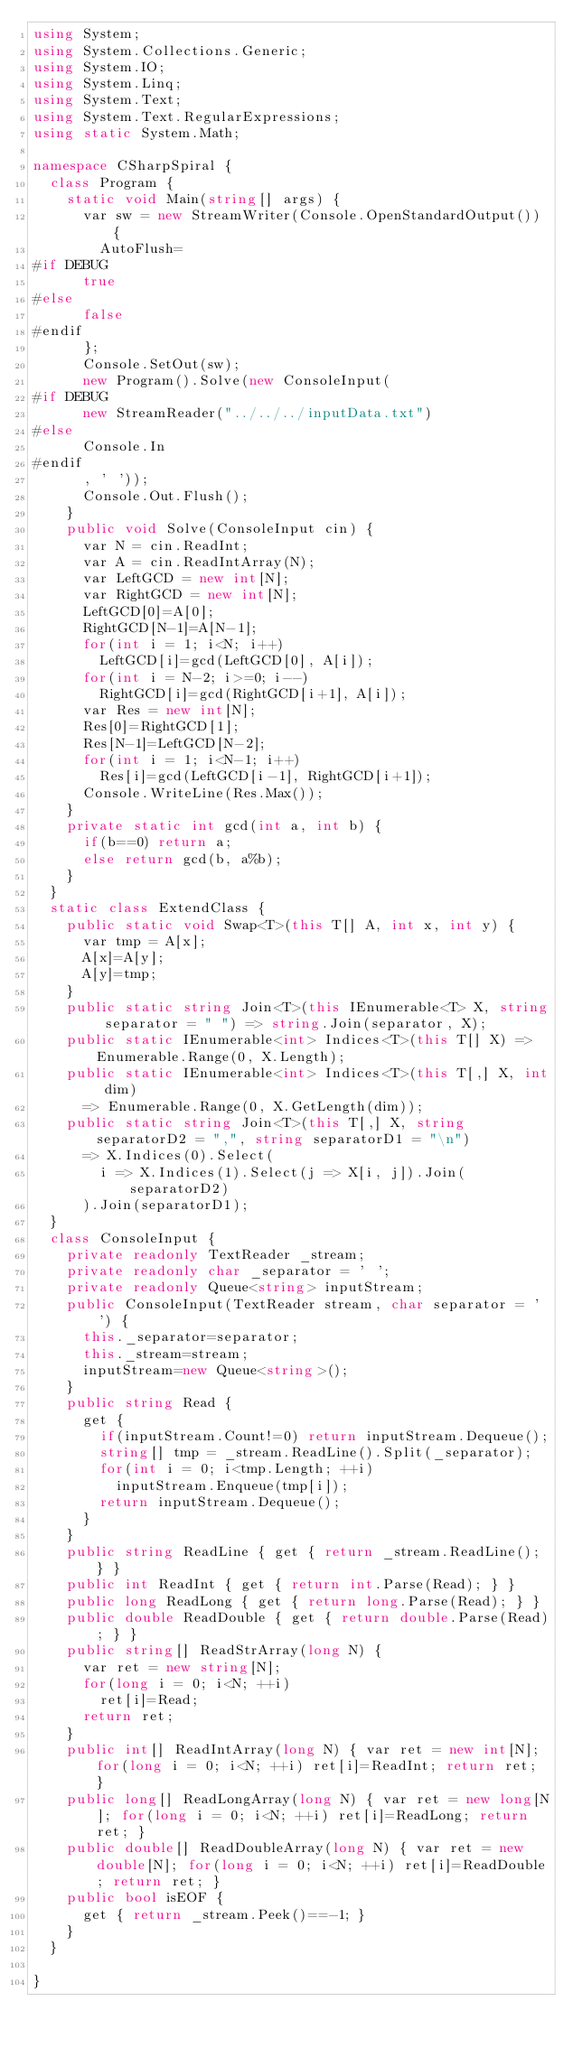<code> <loc_0><loc_0><loc_500><loc_500><_C#_>using System;
using System.Collections.Generic;
using System.IO;
using System.Linq;
using System.Text;
using System.Text.RegularExpressions;
using static System.Math;

namespace CSharpSpiral {
	class Program {
		static void Main(string[] args) {
			var sw = new StreamWriter(Console.OpenStandardOutput()) {
				AutoFlush=
#if DEBUG
			true
#else
			false
#endif
			};
			Console.SetOut(sw);
			new Program().Solve(new ConsoleInput(
#if DEBUG
			new StreamReader("../../../inputData.txt")
#else
			Console.In
#endif
			, ' '));
			Console.Out.Flush();
		}
		public void Solve(ConsoleInput cin) {
			var N = cin.ReadInt;
			var A = cin.ReadIntArray(N);
			var LeftGCD = new int[N];
			var RightGCD = new int[N];
			LeftGCD[0]=A[0];
			RightGCD[N-1]=A[N-1];
			for(int i = 1; i<N; i++) 
				LeftGCD[i]=gcd(LeftGCD[0], A[i]);
			for(int i = N-2; i>=0; i--) 
				RightGCD[i]=gcd(RightGCD[i+1], A[i]);
			var Res = new int[N];
			Res[0]=RightGCD[1];
			Res[N-1]=LeftGCD[N-2];
			for(int i = 1; i<N-1; i++) 
				Res[i]=gcd(LeftGCD[i-1], RightGCD[i+1]);
			Console.WriteLine(Res.Max());
		}
		private static int gcd(int a, int b) {
			if(b==0) return a;
			else return gcd(b, a%b);
		}
	}
	static class ExtendClass {
		public static void Swap<T>(this T[] A, int x, int y) {
			var tmp = A[x];
			A[x]=A[y];
			A[y]=tmp;
		}
		public static string Join<T>(this IEnumerable<T> X, string separator = " ") => string.Join(separator, X);
		public static IEnumerable<int> Indices<T>(this T[] X) => Enumerable.Range(0, X.Length);
		public static IEnumerable<int> Indices<T>(this T[,] X, int dim)
			=> Enumerable.Range(0, X.GetLength(dim));
		public static string Join<T>(this T[,] X, string separatorD2 = ",", string separatorD1 = "\n")
			=> X.Indices(0).Select(
				i => X.Indices(1).Select(j => X[i, j]).Join(separatorD2)
			).Join(separatorD1);
	}
	class ConsoleInput {
		private readonly TextReader _stream;
		private readonly char _separator = ' ';
		private readonly Queue<string> inputStream;
		public ConsoleInput(TextReader stream, char separator = ' ') {
			this._separator=separator;
			this._stream=stream;
			inputStream=new Queue<string>();
		}
		public string Read {
			get {
				if(inputStream.Count!=0) return inputStream.Dequeue();
				string[] tmp = _stream.ReadLine().Split(_separator);
				for(int i = 0; i<tmp.Length; ++i)
					inputStream.Enqueue(tmp[i]);
				return inputStream.Dequeue();
			}
		}
		public string ReadLine { get { return _stream.ReadLine(); } }
		public int ReadInt { get { return int.Parse(Read); } }
		public long ReadLong { get { return long.Parse(Read); } }
		public double ReadDouble { get { return double.Parse(Read); } }
		public string[] ReadStrArray(long N) {
			var ret = new string[N];
			for(long i = 0; i<N; ++i)
				ret[i]=Read;
			return ret;
		}
		public int[] ReadIntArray(long N) { var ret = new int[N]; for(long i = 0; i<N; ++i) ret[i]=ReadInt; return ret; }
		public long[] ReadLongArray(long N) { var ret = new long[N]; for(long i = 0; i<N; ++i) ret[i]=ReadLong; return ret; }
		public double[] ReadDoubleArray(long N) { var ret = new double[N]; for(long i = 0; i<N; ++i) ret[i]=ReadDouble; return ret; }
		public bool isEOF {
			get { return _stream.Peek()==-1; }
		}
	}

}</code> 